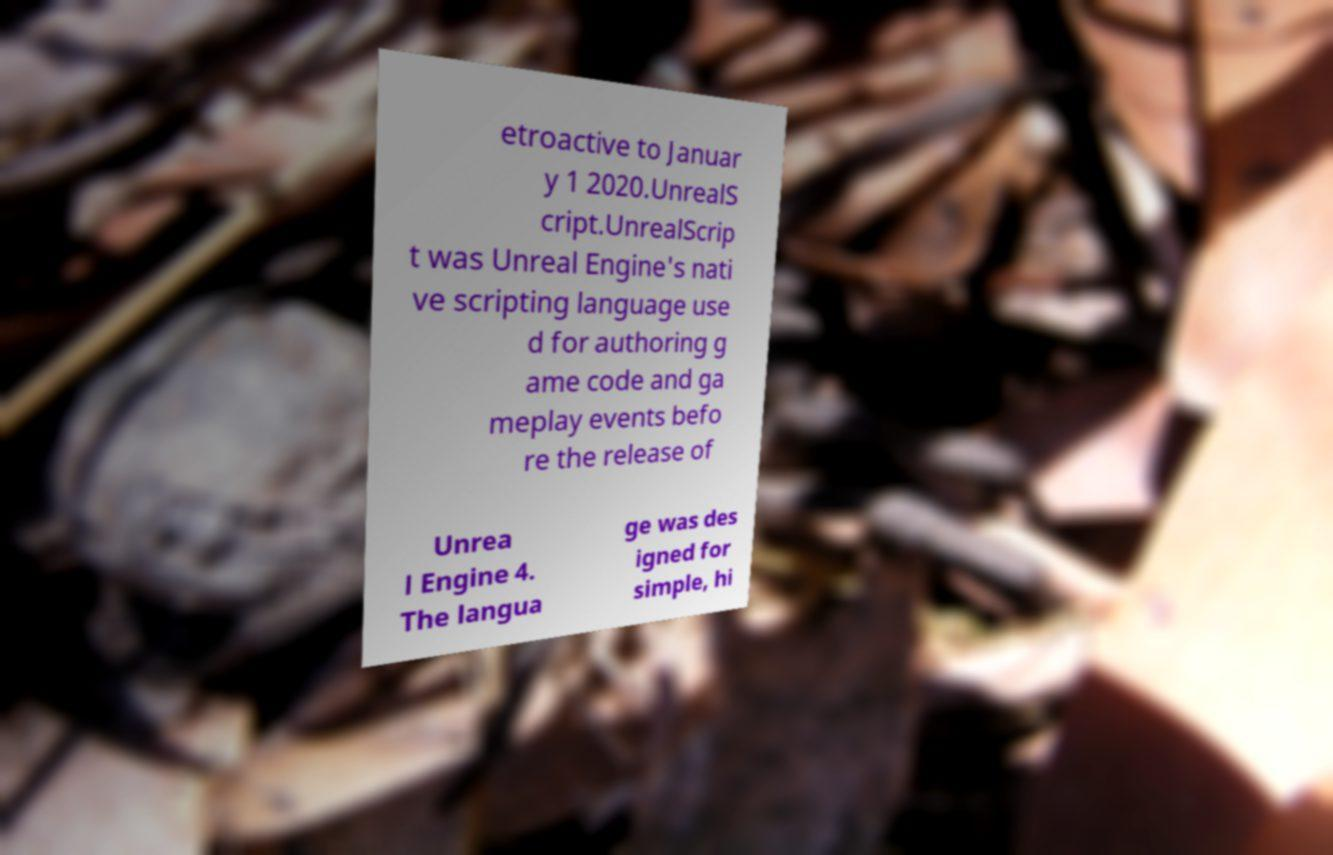Please identify and transcribe the text found in this image. etroactive to Januar y 1 2020.UnrealS cript.UnrealScrip t was Unreal Engine's nati ve scripting language use d for authoring g ame code and ga meplay events befo re the release of Unrea l Engine 4. The langua ge was des igned for simple, hi 